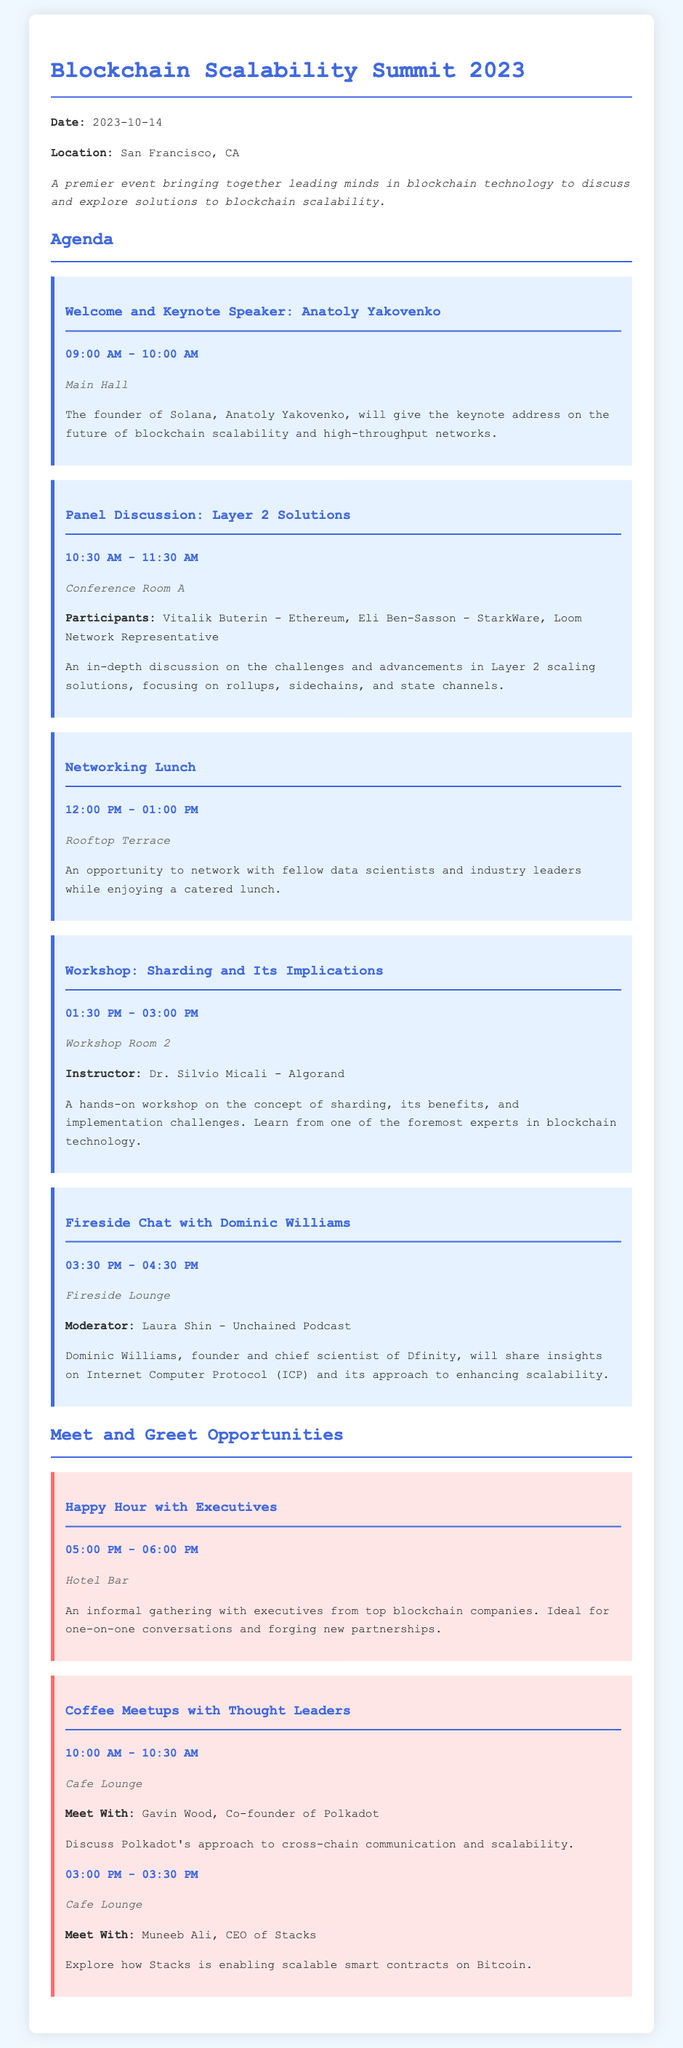What is the date of the event? The date of the event is explicitly stated in the document as October 14, 2023.
Answer: October 14, 2023 Who is the keynote speaker? The document lists Anatoly Yakovenko as the keynote speaker for the event.
Answer: Anatoly Yakovenko What time does the Panel Discussion start? The start time for the Panel Discussion is provided, which is 10:30 AM.
Answer: 10:30 AM Where is the Networking Lunch held? The location for the Networking Lunch is specified as the Rooftop Terrace in the document.
Answer: Rooftop Terrace Who will moderate the Fireside Chat? The document identifies Laura Shin as the moderator for the Fireside Chat.
Answer: Laura Shin What type of networking opportunity is available at 5:00 PM? The document describes an informal gathering called Happy Hour with Executives scheduled at 5:00 PM.
Answer: Happy Hour with Executives How long is the Workshop on Sharding? The duration of the Workshop on Sharding is mentioned as 1.5 hours or 90 minutes.
Answer: 1.5 hours Which two individuals can be met during Coffee Meetups? The document explicitly states the names of Gavin Wood and Muneeb Ali as individuals available for meetups.
Answer: Gavin Wood, Muneeb Ali 